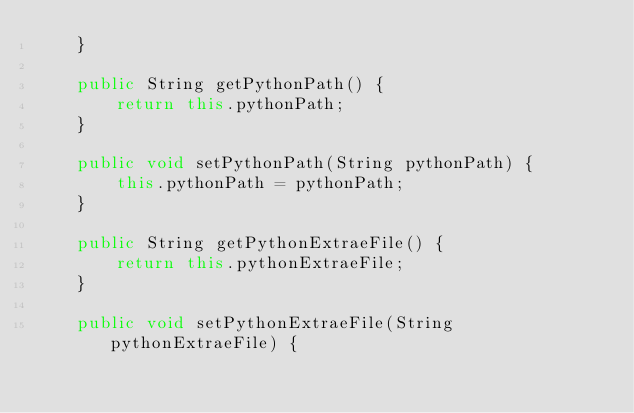Convert code to text. <code><loc_0><loc_0><loc_500><loc_500><_Java_>    }

    public String getPythonPath() {
        return this.pythonPath;
    }

    public void setPythonPath(String pythonPath) {
        this.pythonPath = pythonPath;
    }

    public String getPythonExtraeFile() {
        return this.pythonExtraeFile;
    }

    public void setPythonExtraeFile(String pythonExtraeFile) {</code> 